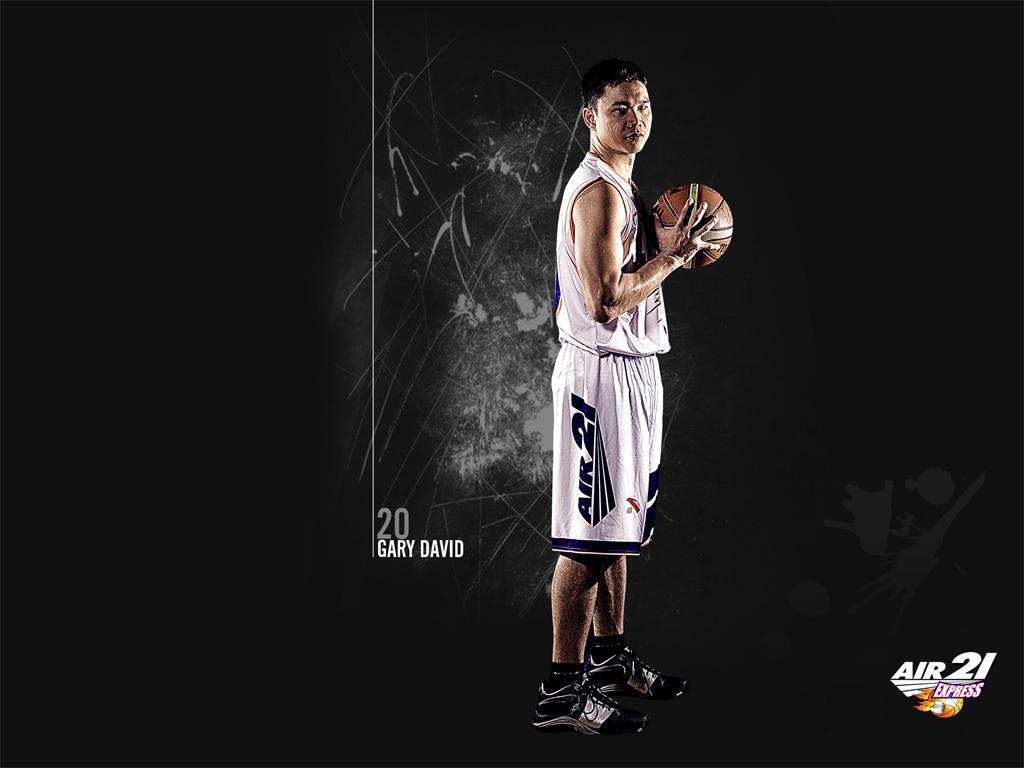Can you describe this image briefly? In this image I can see the person standing and holding the ball and the person is wearing white color dress and I can see the dark background. 